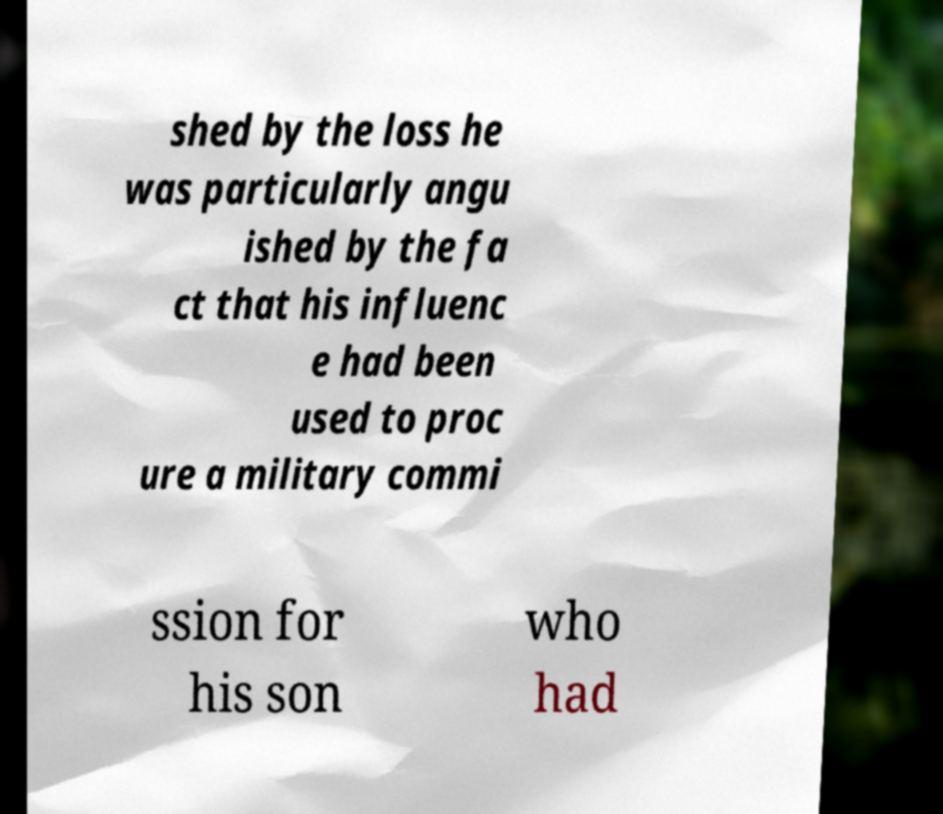Could you extract and type out the text from this image? shed by the loss he was particularly angu ished by the fa ct that his influenc e had been used to proc ure a military commi ssion for his son who had 